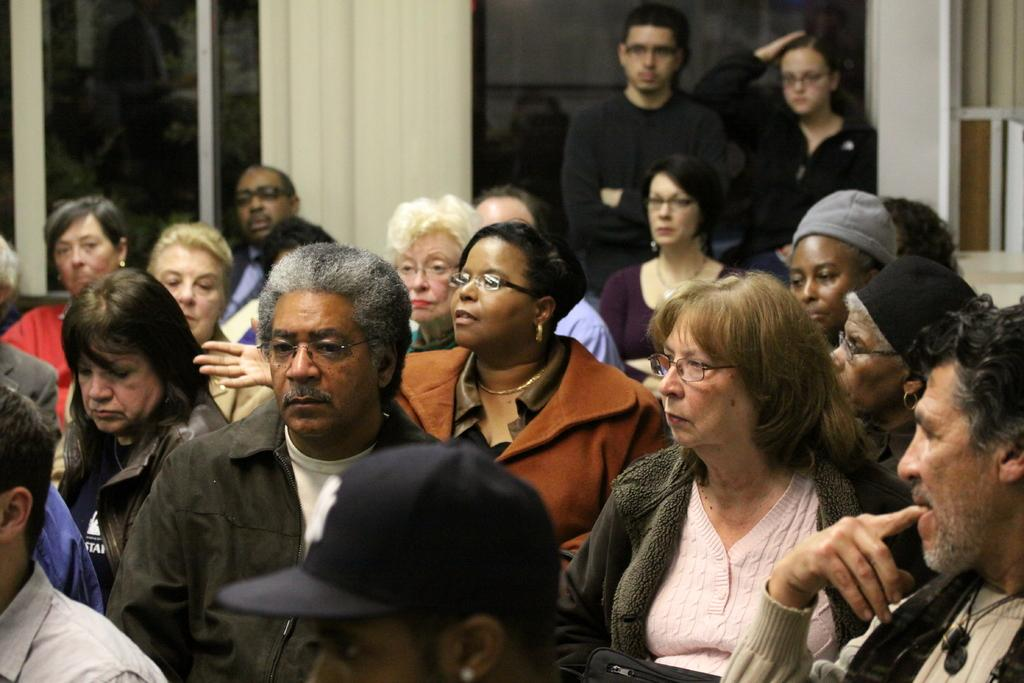What are the people in the image doing? The people in the image are sitting on chairs. What can be seen in the background of the image? There is a wall and windows in the background of the image. Are there any other people visible in the image? Yes, two people are standing in the background of the image. What type of brass instrument is being played by the people in the image? There is no brass instrument present in the image; the people are sitting on chairs. 